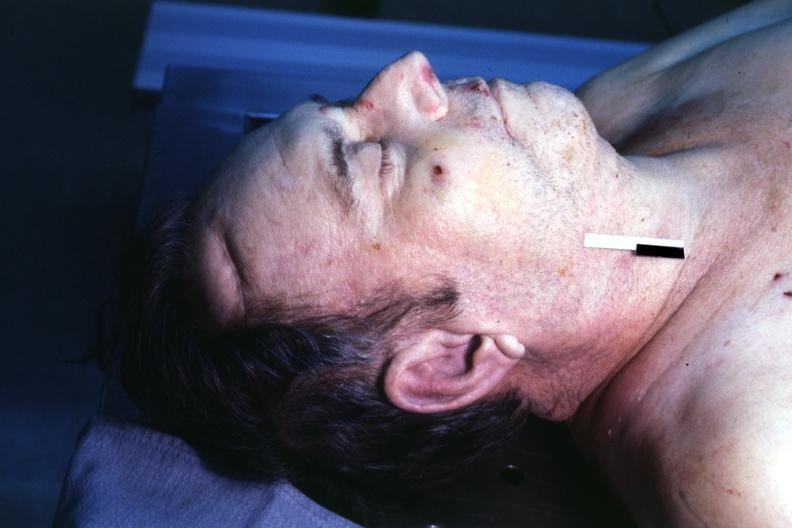s premature coronary disease easily seen?
Answer the question using a single word or phrase. Yes 